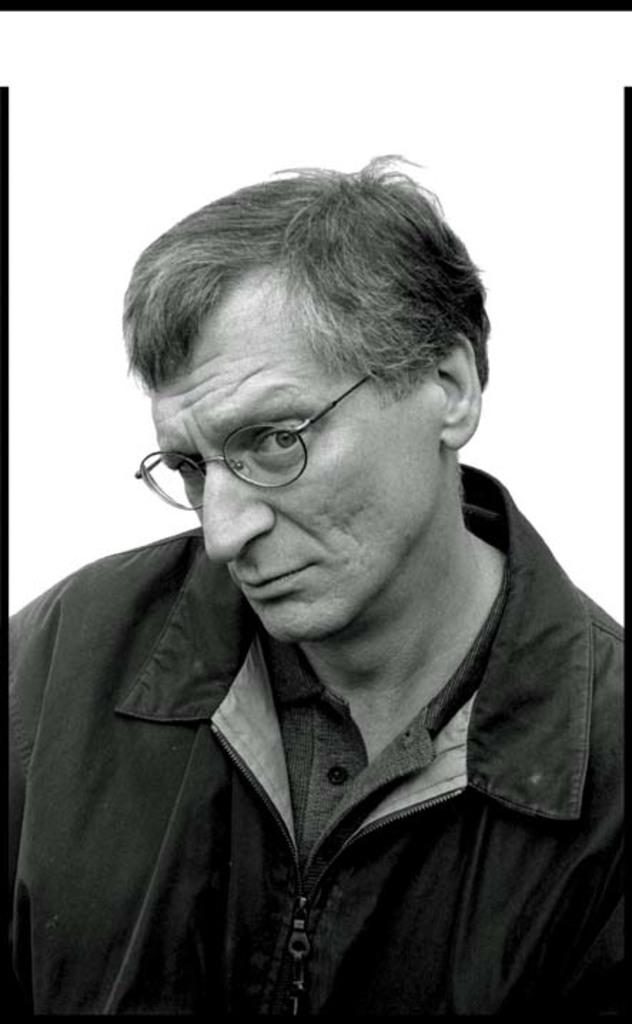What is the main subject of the picture? The main subject of the picture is a man. What can be observed about the man's appearance? The man is wearing spectacles. What is the color scheme of the picture? The picture is in black and white. What type of boot is the man wearing in the picture? The picture is in black and white, and there is no mention of any boots or footwear in the provided facts. Therefore, it cannot be determined what type of boot the man is wearing. 